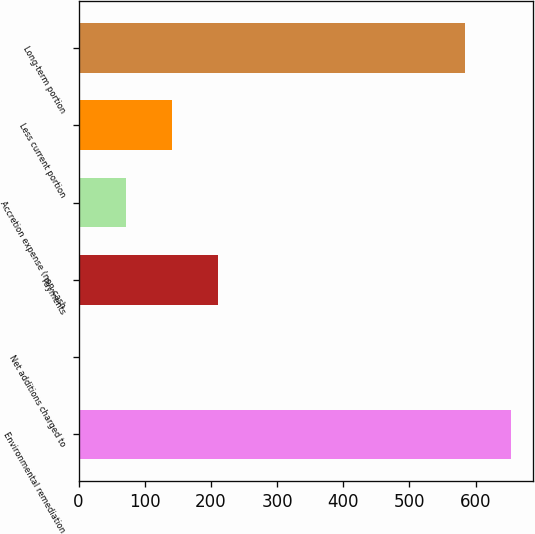Convert chart to OTSL. <chart><loc_0><loc_0><loc_500><loc_500><bar_chart><fcel>Environmental remediation<fcel>Net additions charged to<fcel>Payments<fcel>Accretion expense (non-cash<fcel>Less current portion<fcel>Long-term portion<nl><fcel>653.29<fcel>1.6<fcel>210.37<fcel>71.19<fcel>140.78<fcel>583.7<nl></chart> 